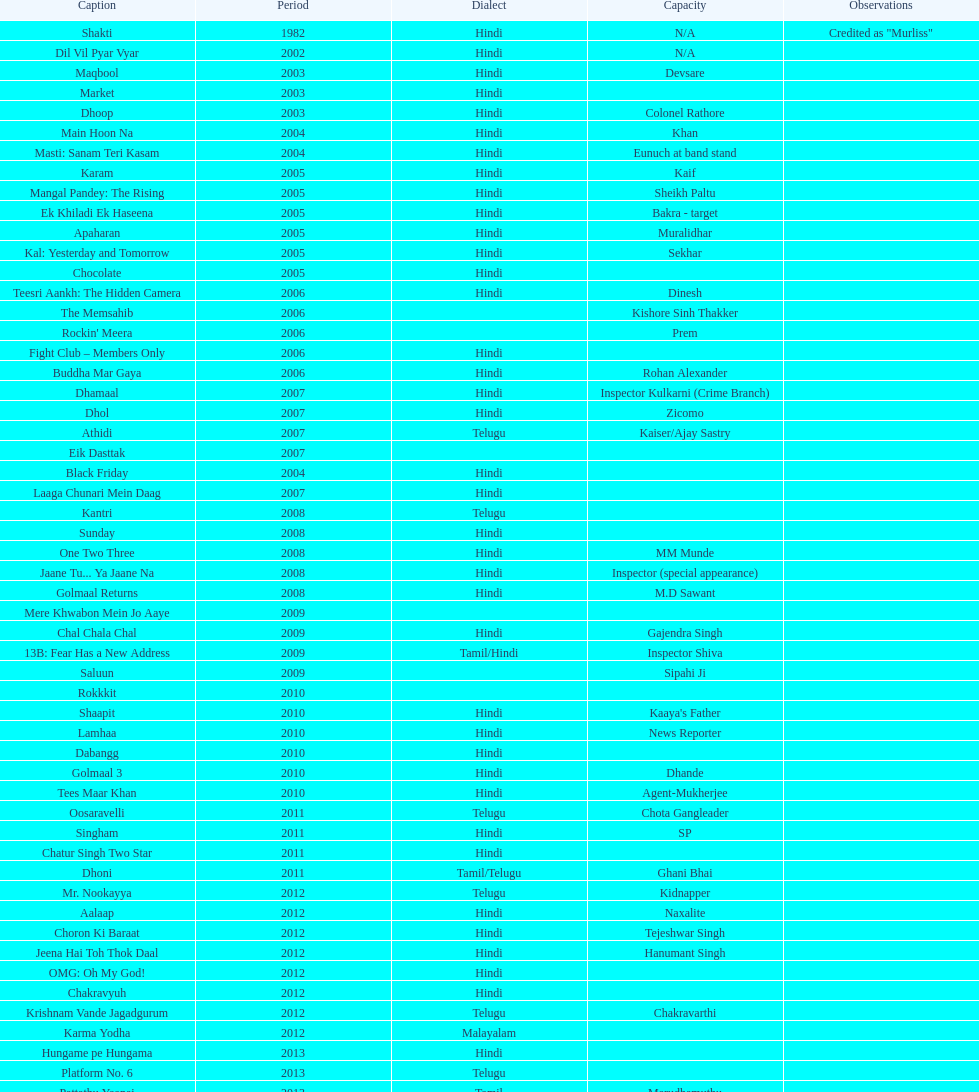What is the first language after hindi Telugu. 